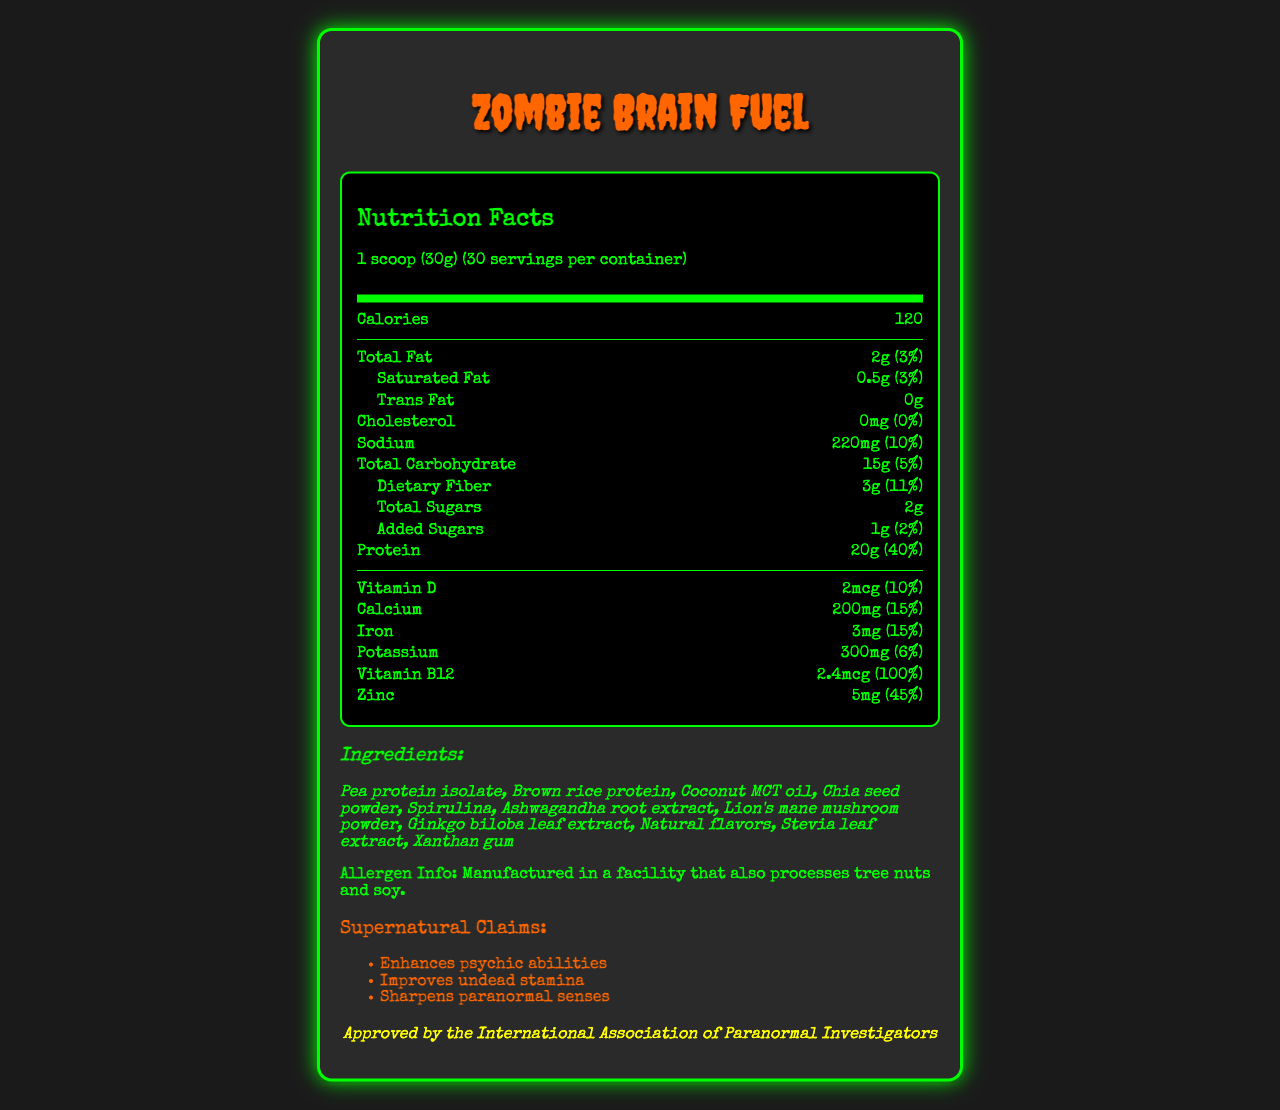what is the serving size for Zombie Brain Fuel? The serving size is explicitly stated in the document as "1 scoop (30g)".
Answer: 1 scoop (30g) how much protein is in one serving of Zombie Brain Fuel? Under the "Protein" section, it lists 20g for one serving.
Answer: 20g what supernatural claims does Zombie Brain Fuel make? The document includes a section labeled "Supernatural Claims" which lists these three points.
Answer: Enhances psychic abilities, Improves undead stamina, Sharpens paranormal senses how much sodium is in a serving? The document mentions that each serving contains 220mg of sodium.
Answer: 220mg what is the allergen information provided for Zombie Brain Fuel? The allergen information is clearly stated near the bottom of the document.
Answer: Manufactured in a facility that also processes tree nuts and soy. how many servings are in one container? The label indicates that there are 30 servings per container.
Answer: 30 which ingredient is listed second in the ingredients list? A. Pea protein isolate B. Brown rice protein C. Coconut MCT oil The second ingredient listed is Brown rice protein.
Answer: B what is the daily value percentage of dietary fiber in one serving? A. 5% B. 10% C. 11% The daily value percentage of dietary fiber in one serving is 11%.
Answer: C does Zombie Brain Fuel contain any trans fat? The document clearly states that there is 0g of trans fat.
Answer: No is there any iron in Zombie Brain Fuel? The document lists iron with an amount of 3mg and a daily value of 15%.
Answer: Yes summarize the main nutritional information and supernatural claims made by Zombie Brain Fuel. The explanation summarizes the main nutritional components, supernatural claims, allergen information, and the fictional endorsement.
Answer: Zombie Brain Fuel is a meal replacement powder with 120 calories per serving. Each serving offers 20g of protein, 15g of carbohydrates (including 3g of dietary fiber and 2g of total sugars), and 2g of total fat. Key vitamins and minerals include Vitamin D, Calcium, Iron, Potassium, Vitamin B12, and Zinc. It claims to enhance psychic abilities, improve undead stamina, and sharpen paranormal senses. The product is manufactured in a facility that processes tree nuts and soy. It has received a fictional endorsement from the International Association of Paranormal Investigators. what is the total carbohydrate content per serving? The total carbohydrate content per serving is specified as 15g.
Answer: 15g is Zombie Brain Fuel endorsed by any fictional organizations? The document mentions that it is "Approved by the International Association of Paranormal Investigators".
Answer: Yes how much added sugar is in one serving of Zombie Brain Fuel? The document states that added sugars amount to 1g per serving.
Answer: 1g what vitamins and minerals are included in Zombie Brain Fuel? The document lists these vitamins and minerals with their respective amounts and daily values.
Answer: Vitamin D, Calcium, Iron, Potassium, Vitamin B12, Zinc what is the daily value percentage of Calcium in one serving? The daily value percentage of Calcium is listed as 15%.
Answer: 15% are there any GMO ingredients in Zombie Brain Fuel? The document does not provide any information regarding GMO ingredients.
Answer: Cannot be determined 